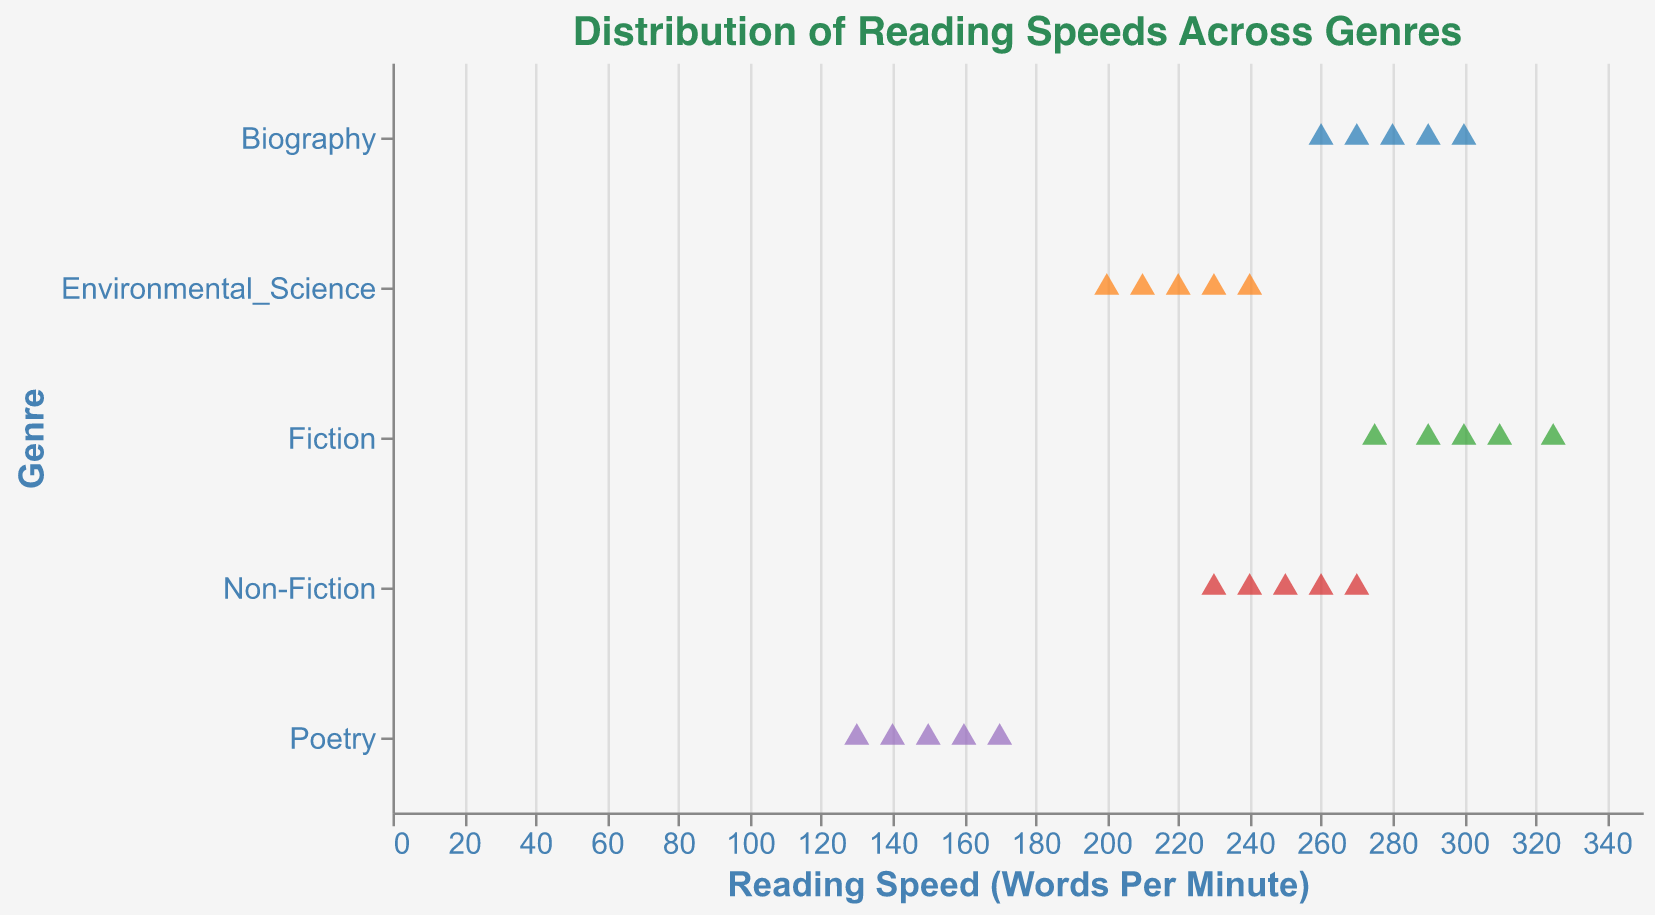What is the title of the plot? The title of the plot is displayed at the top and reads "Distribution of Reading Speeds Across Genres".
Answer: Distribution of Reading Speeds Across Genres What is the range of reading speeds for Fiction? The reading speeds for Fiction can be seen along the x-axis where the data points are plotted. The range stretches from the lowest value (275 WPM) to the highest value (325 WPM).
Answer: 275 to 325 WPM Which genre has the highest average reading speed? To find the average reading speed for each genre, we must sum the reading speeds within each genre and divide by the number of data points. Biography has the highest average (280 + 260 + 300 + 270 + 290 = 1400; 1400/5 = 280 WPM).
Answer: Biography What is the lowest reading speed recorded for any genre? The lowest reading speed can be identified by looking for the left-most point on the x-axis, which corresponds to Poetry with 130 WPM.
Answer: 130 WPM How does the average reading speed of Non-Fiction compare to Fiction? Calculate the average for Non-Fiction (250 + 230 + 270 + 240 + 260 = 1250; 1250/5 = 250 WPM) and Fiction (300 + 275 + 325 + 290 + 310 = 1500; 1500/5 = 300 WPM). Fiction has a higher average speed than Non-Fiction.
Answer: Fiction has a higher average reading speed Which genre shows the smallest range of reading speeds? The range is calculated by the difference between the highest and lowest reading speeds within each genre. Poetry has the smallest range (170 - 130 = 40 WPM).
Answer: Poetry How many data points are there for Environmental Science? Count the number of points for Environmental Science by observing the plot. There are 5 data points.
Answer: 5 Is there any overlap in the reading speeds between Non-Fiction and Biography? Compare the ranges: Non-Fiction (230 to 270 WPM) and Biography (260 to 300 WPM). They overlap between 260 and 270 WPM.
Answer: Yes What is the most common shape used to represent data points in the plot? The data points are represented by triangles filled in the plot.
Answer: Triangle What is the main color scheme used in the plot? Observe the colors of the data points which use various contrasting colors from the "category10" color scheme, commonly appearing in strip plots to distinguish different genres.
Answer: category10 color scheme 